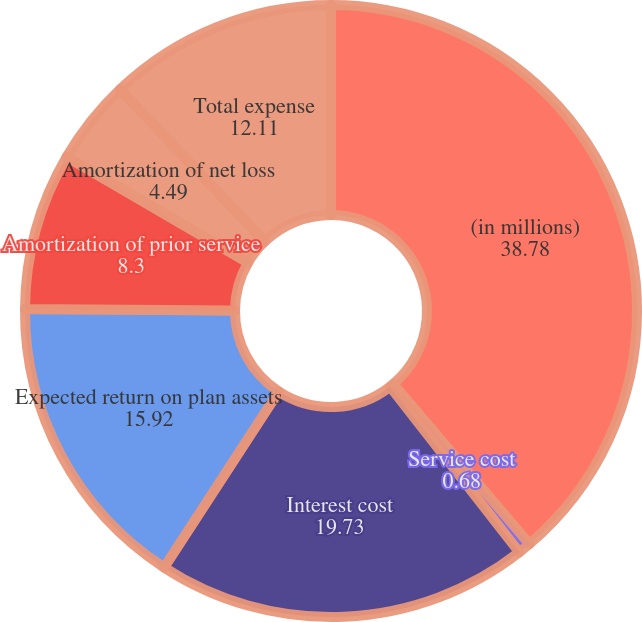Convert chart to OTSL. <chart><loc_0><loc_0><loc_500><loc_500><pie_chart><fcel>(in millions)<fcel>Service cost<fcel>Interest cost<fcel>Expected return on plan assets<fcel>Amortization of prior service<fcel>Amortization of net loss<fcel>Total expense<nl><fcel>38.78%<fcel>0.68%<fcel>19.73%<fcel>15.92%<fcel>8.3%<fcel>4.49%<fcel>12.11%<nl></chart> 